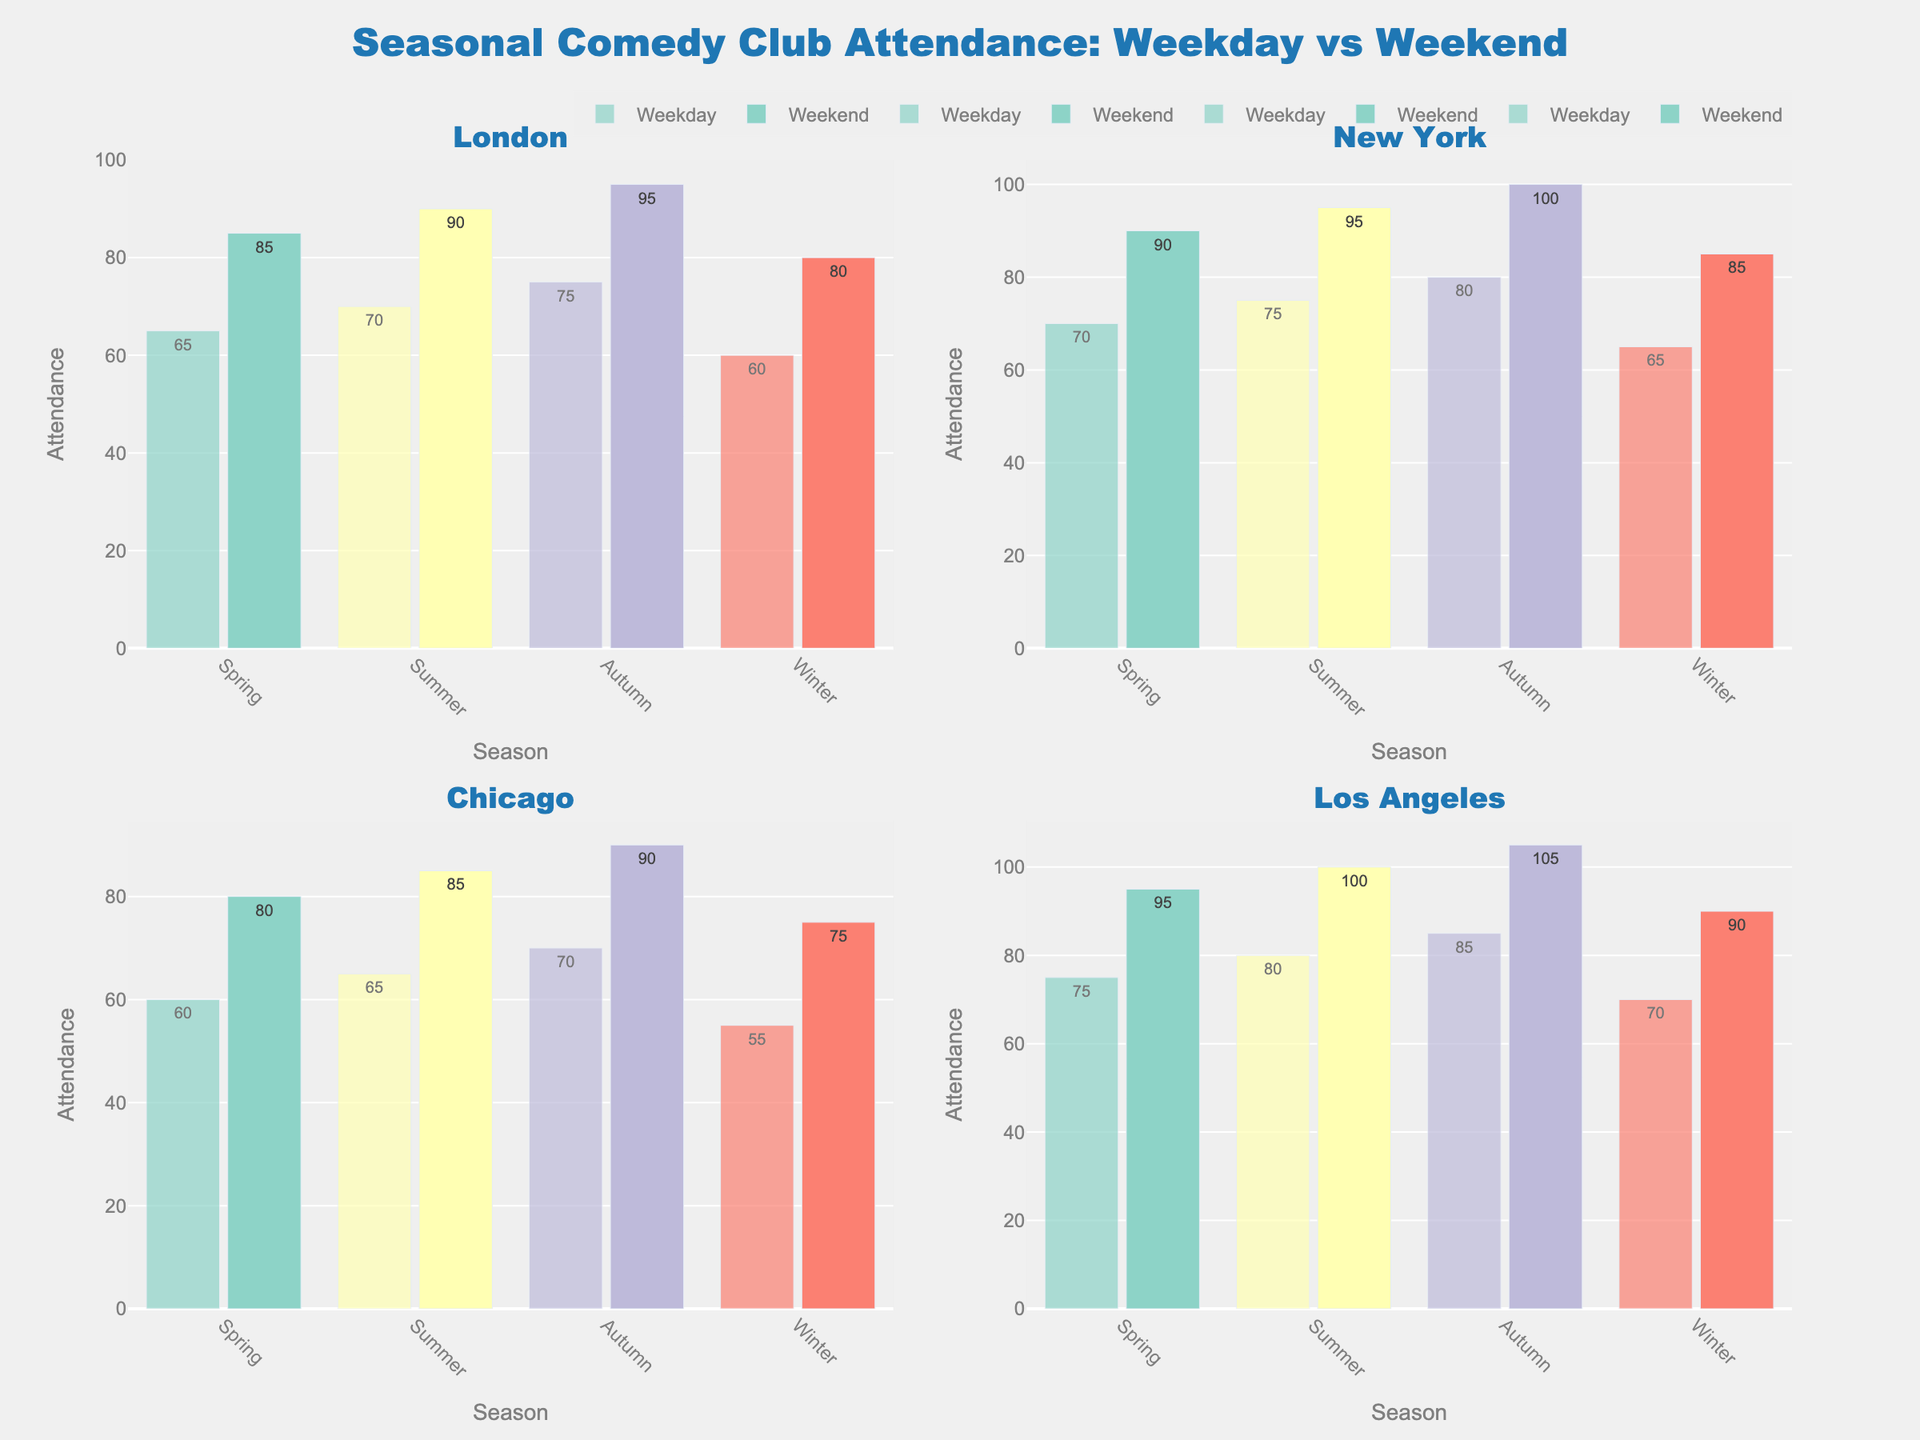What's the overall attendance trend in London across all seasons? Look at London's subplot and examine the attendance bars across the four seasons. The weekday attendance increases from spring to autumn, then drops in winter. The weekend attendance follows a similar pattern.
Answer: Upward trend till autumn, then slight drop in winter Which city has the highest weekend attendance in autumn? Check all the subplots for the highest weekend attendance bar in autumn. The highest is in Los Angeles.
Answer: Los Angeles What is the difference between weekday and weekend attendance in summer for Chicago? Find the weekday and weekend bars for summer in the Chicago subplot. Weekend attendance is 85, and weekday attendance is 65. Calculate 85 - 65.
Answer: 20 Which city shows the least variation between weekday and weekend attendance across all seasons? Compare the length of the gaps between paired bars for each city. The city with the most consistent small gaps has the least variation. London shows the smallest gaps.
Answer: London How does New York’s winter attendance compare to Chicago’s winter attendance? Compare winter data bars between New York and Chicago. New York's weekday (65) and weekend (85) attendance are higher than Chicago's (55 and 75).
Answer: New York has higher attendance Are the weekend attendance rates consistently higher than weekday rates in Los Angeles across all seasons? Look at Los Angeles's subplot and compare the weekday and weekend bars for all four seasons. The weekend bars are always higher.
Answer: Yes In which city does summer show the highest increase from weekday to weekend attendance? Check the summer subplot for each city. Find the one with the largest difference between weekday and weekend attendance. Los Angeles increases from 80 to 100.
Answer: Los Angeles What's the average weekend attendance for New York across all seasons? Sum the weekend attendance values for New York (90 + 95 + 100 + 85) and divide by 4. (370/4 = 92.5)
Answer: 92.5 Which season has the highest weekday attendance across all cities? Identify the highest weekday attendance bar in each subplot and check which season it belongs to. Autumn in New York is the highest with 80.
Answer: Autumn 